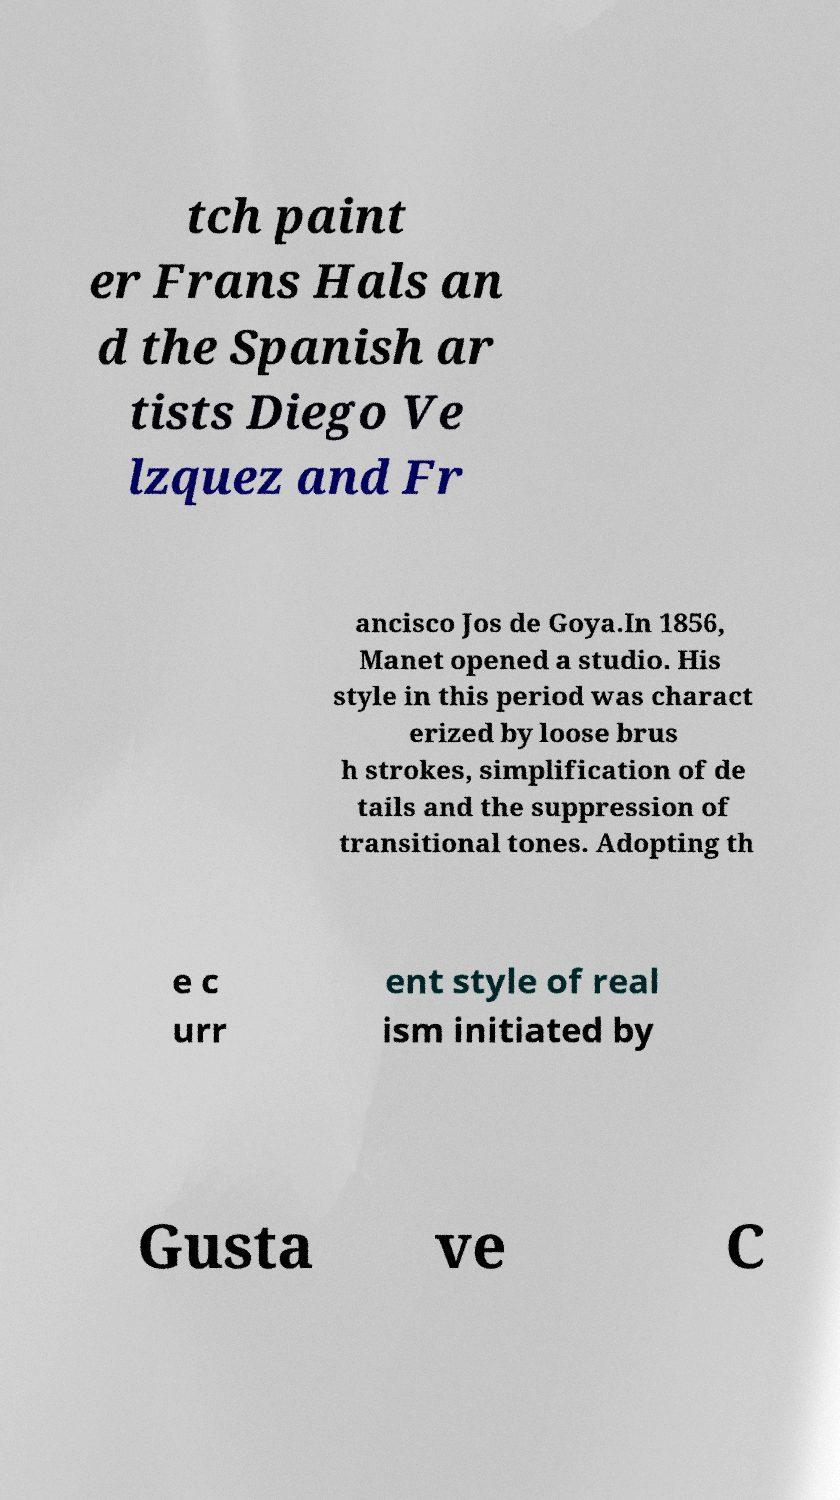There's text embedded in this image that I need extracted. Can you transcribe it verbatim? tch paint er Frans Hals an d the Spanish ar tists Diego Ve lzquez and Fr ancisco Jos de Goya.In 1856, Manet opened a studio. His style in this period was charact erized by loose brus h strokes, simplification of de tails and the suppression of transitional tones. Adopting th e c urr ent style of real ism initiated by Gusta ve C 